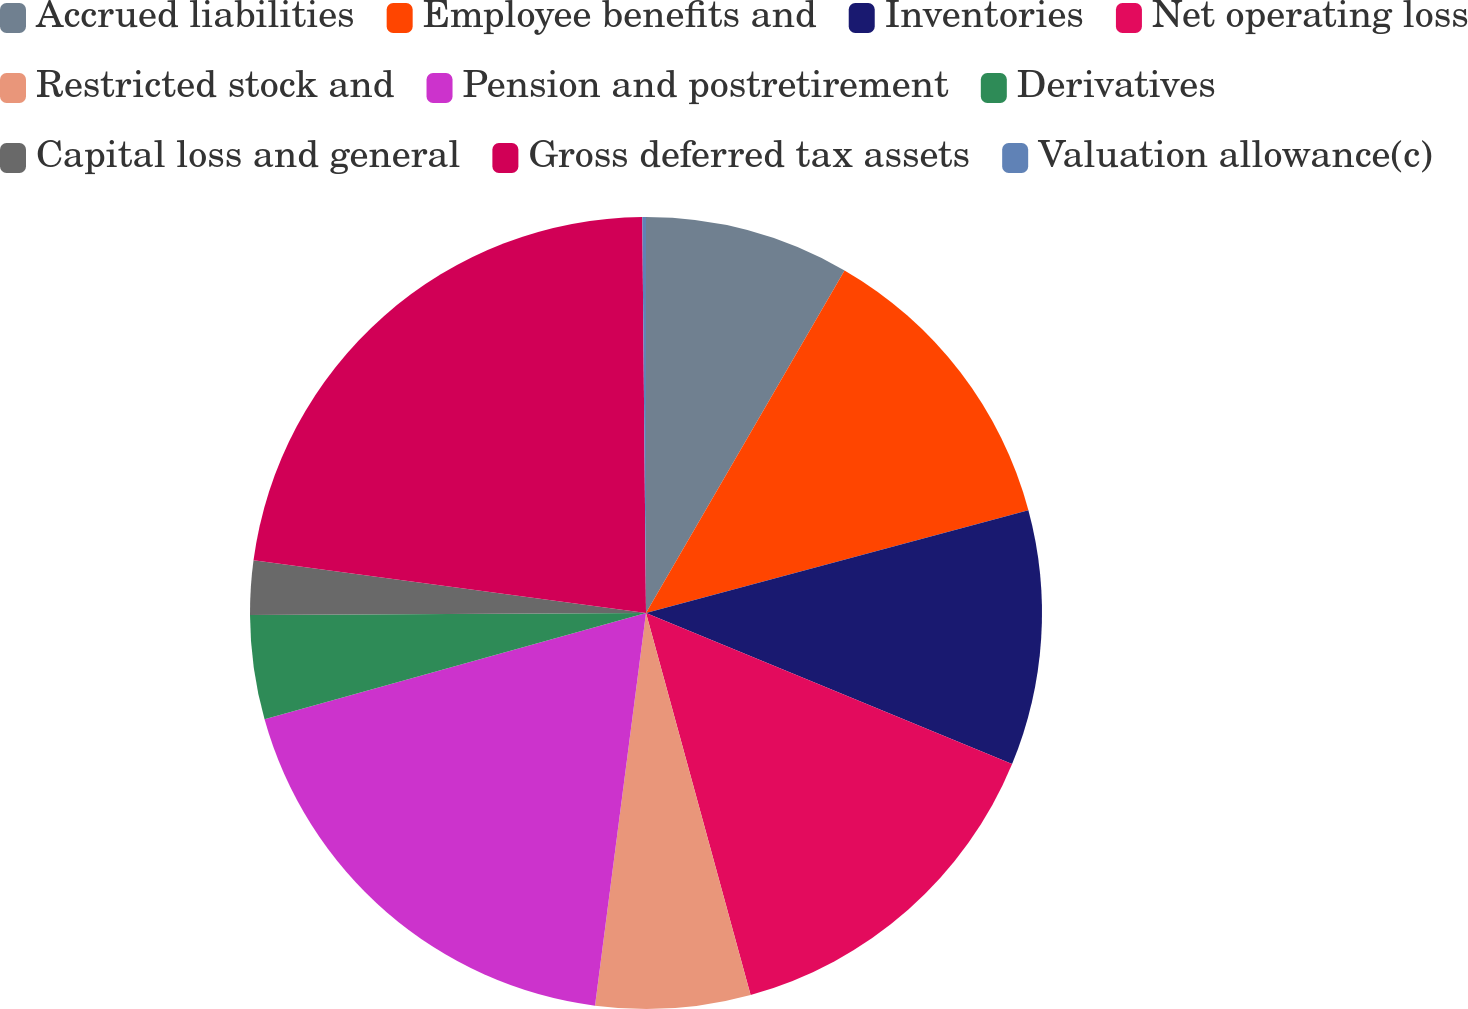Convert chart to OTSL. <chart><loc_0><loc_0><loc_500><loc_500><pie_chart><fcel>Accrued liabilities<fcel>Employee benefits and<fcel>Inventories<fcel>Net operating loss<fcel>Restricted stock and<fcel>Pension and postretirement<fcel>Derivatives<fcel>Capital loss and general<fcel>Gross deferred tax assets<fcel>Valuation allowance(c)<nl><fcel>8.36%<fcel>12.46%<fcel>10.41%<fcel>14.52%<fcel>6.31%<fcel>18.62%<fcel>4.25%<fcel>2.2%<fcel>22.73%<fcel>0.15%<nl></chart> 